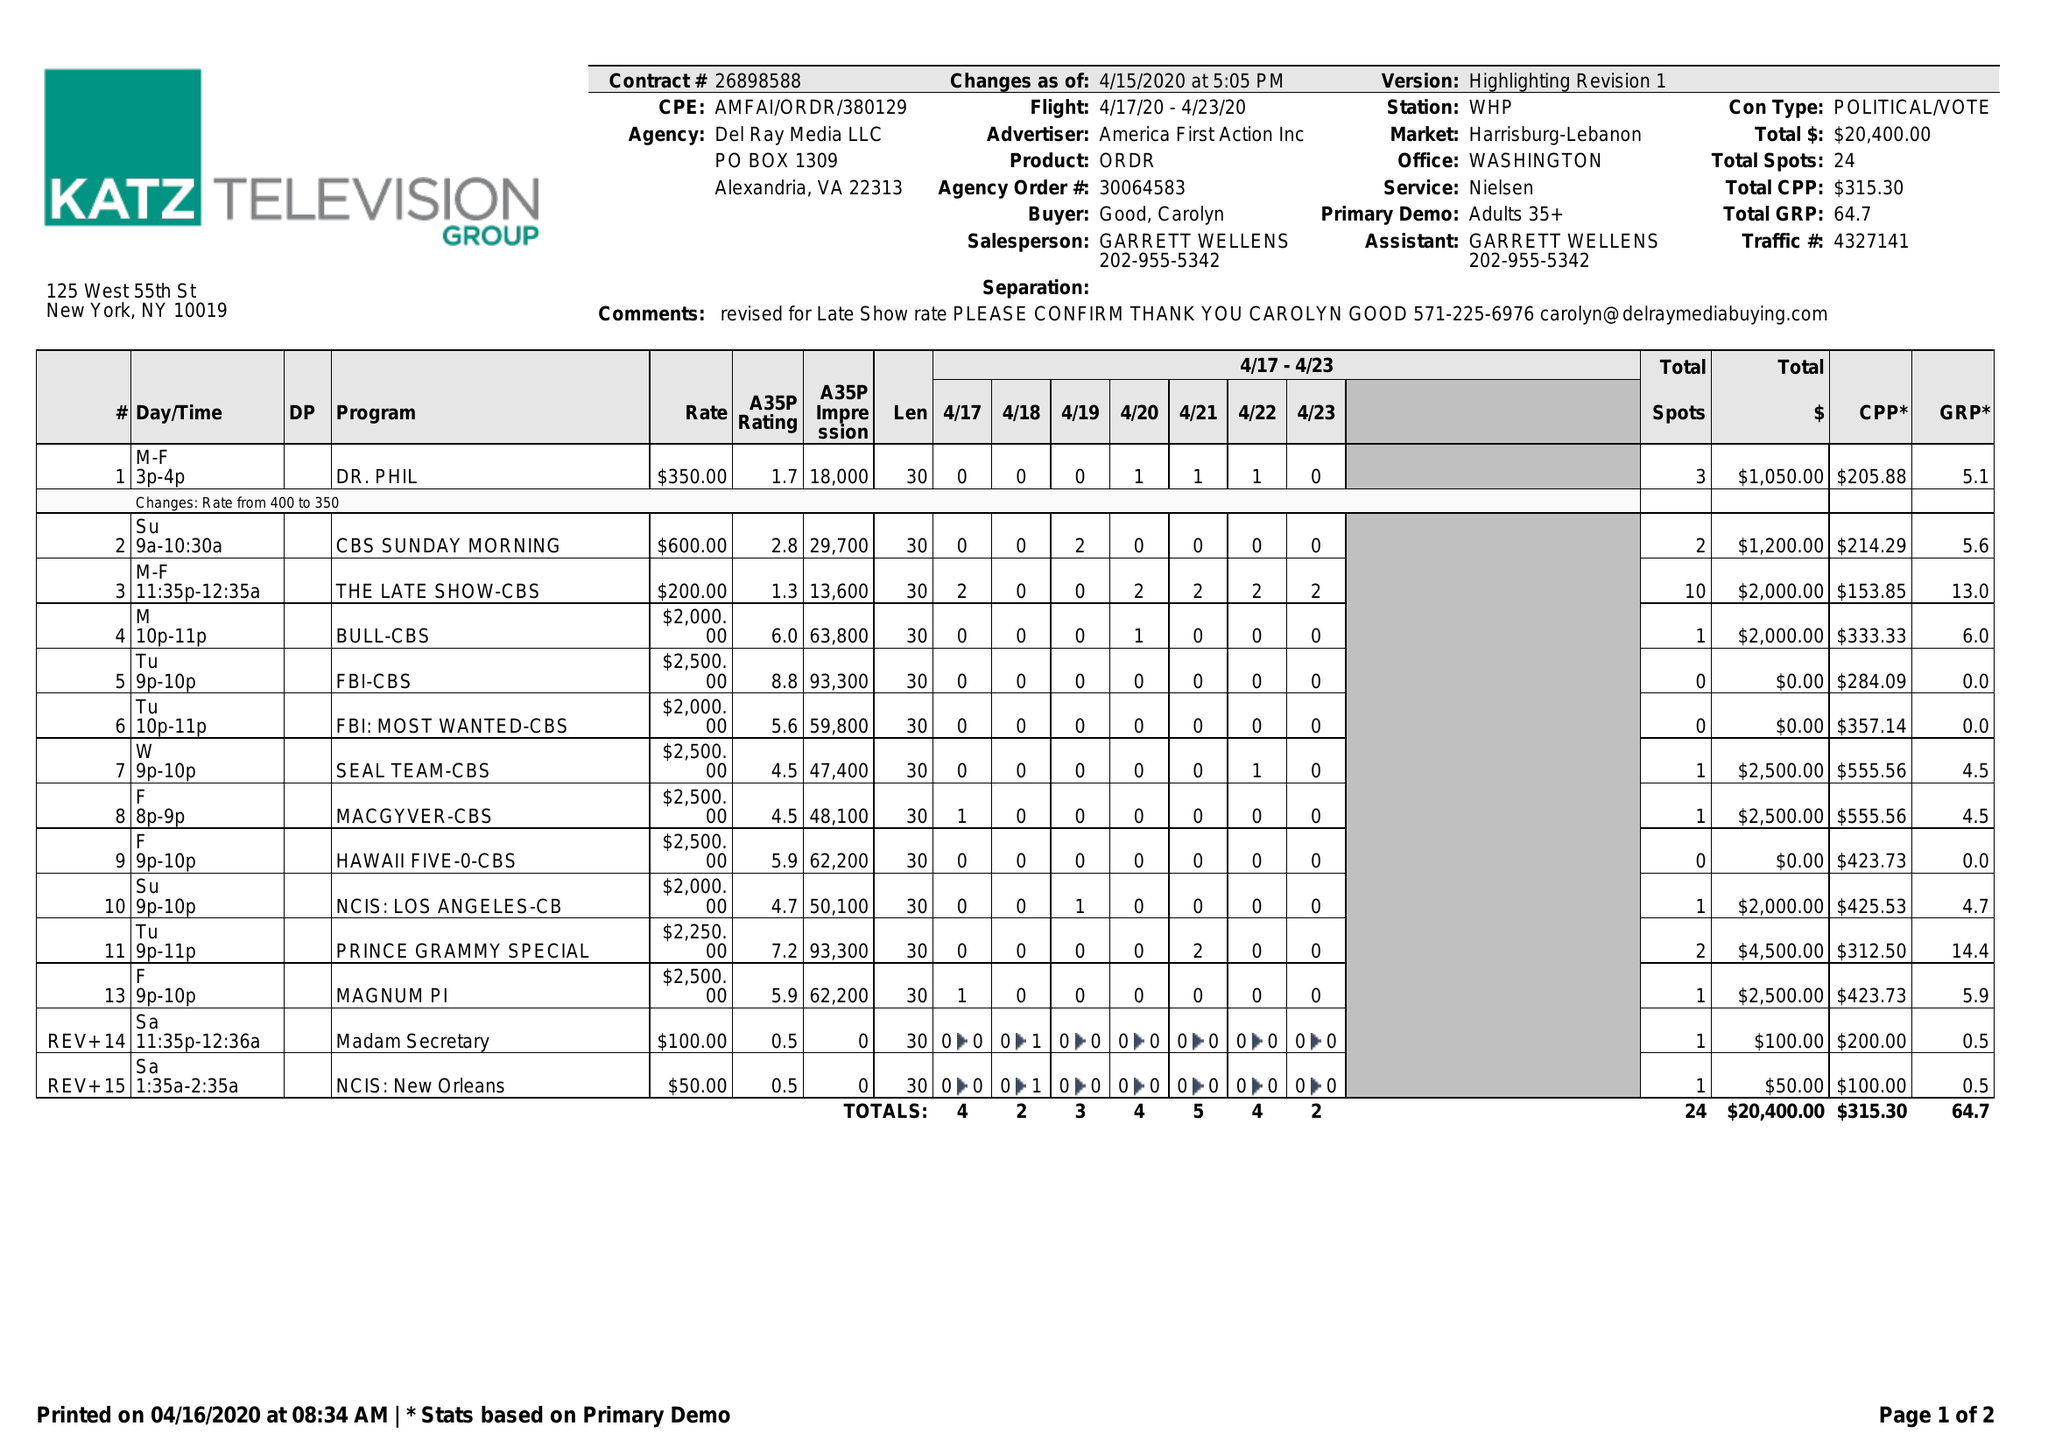What is the value for the advertiser?
Answer the question using a single word or phrase. AMERICA FIRST ACTION INC 